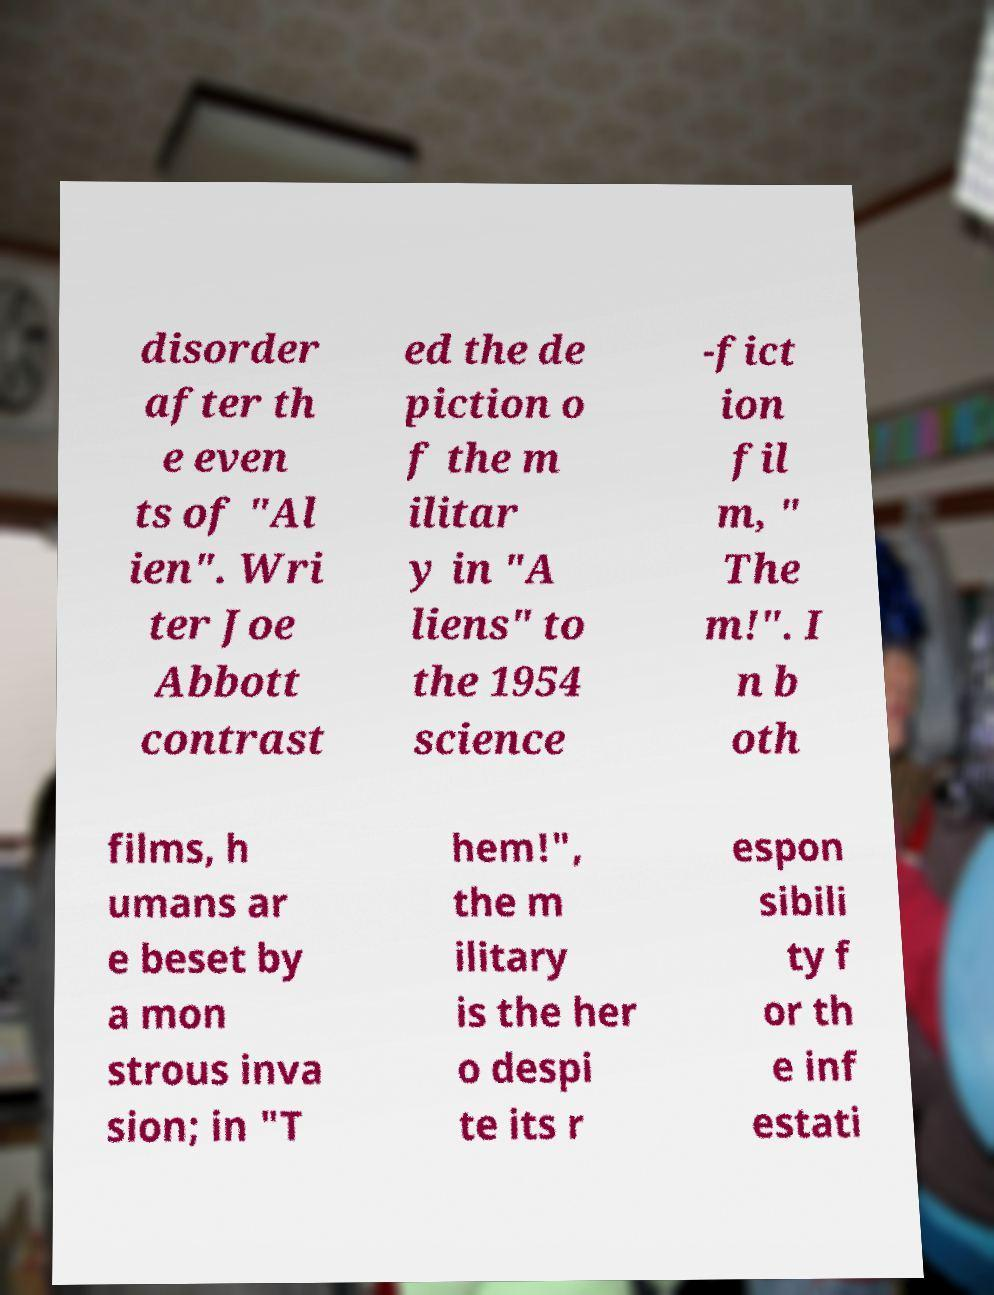Can you read and provide the text displayed in the image?This photo seems to have some interesting text. Can you extract and type it out for me? disorder after th e even ts of "Al ien". Wri ter Joe Abbott contrast ed the de piction o f the m ilitar y in "A liens" to the 1954 science -fict ion fil m, " The m!". I n b oth films, h umans ar e beset by a mon strous inva sion; in "T hem!", the m ilitary is the her o despi te its r espon sibili ty f or th e inf estati 